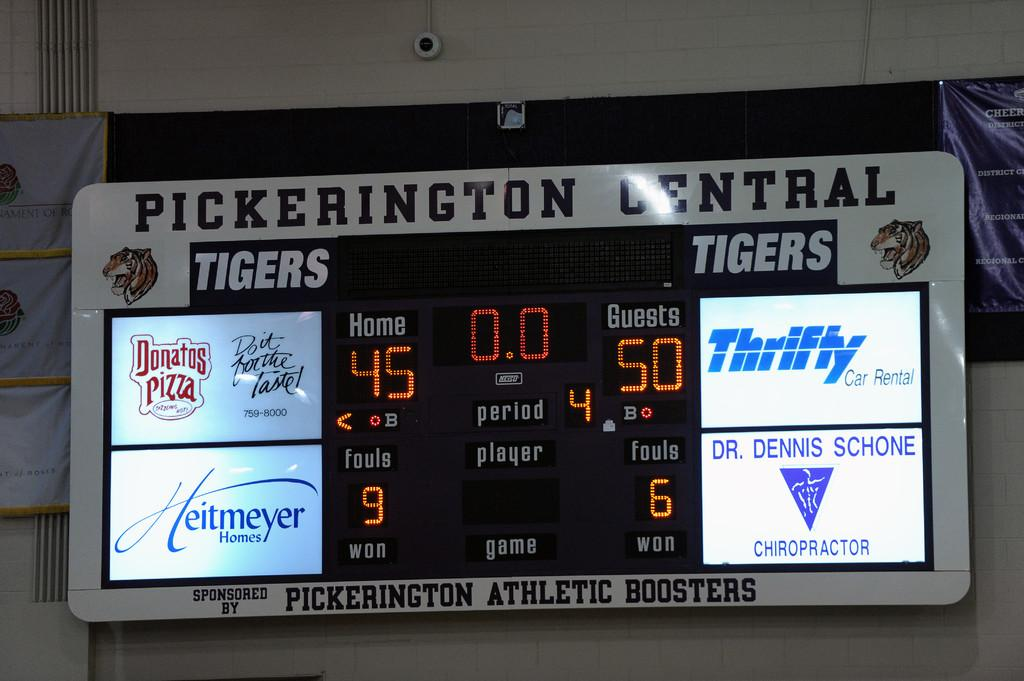<image>
Provide a brief description of the given image. A scoreboard advertising Thrifty and Heitmeyer next to the scores. 